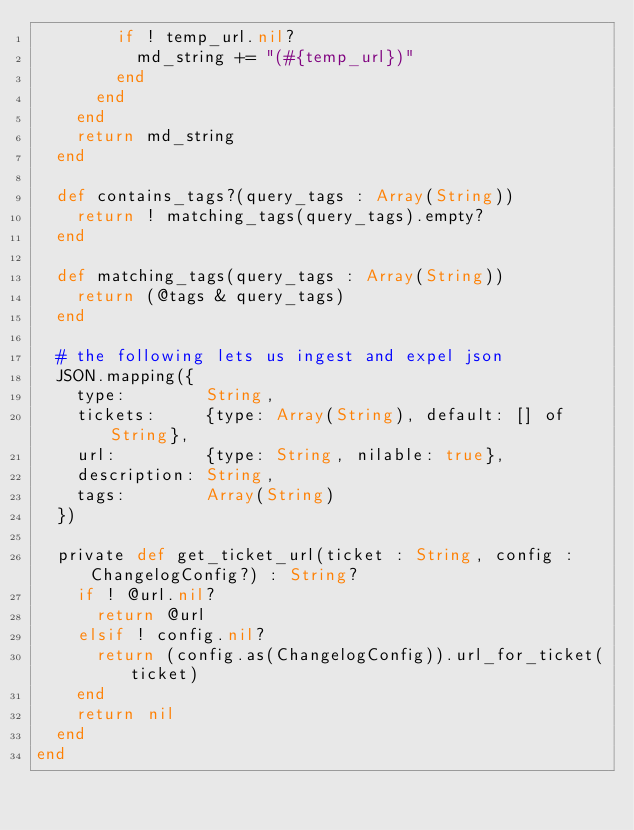<code> <loc_0><loc_0><loc_500><loc_500><_Crystal_>				if ! temp_url.nil?
					md_string += "(#{temp_url})"
				end
			end
		end
		return md_string
	end

	def contains_tags?(query_tags : Array(String))
		return ! matching_tags(query_tags).empty?
	end

	def matching_tags(query_tags : Array(String))
		return (@tags & query_tags)
	end

	# the following lets us ingest and expel json
	JSON.mapping({
		type:        String,
		tickets:     {type: Array(String), default: [] of String},
		url:         {type: String, nilable: true},
		description: String,
		tags:        Array(String)
	})

	private def get_ticket_url(ticket : String, config : ChangelogConfig?) : String?
		if ! @url.nil?
			return @url
		elsif ! config.nil?
			return (config.as(ChangelogConfig)).url_for_ticket(ticket)
		end
		return nil
	end
end


</code> 